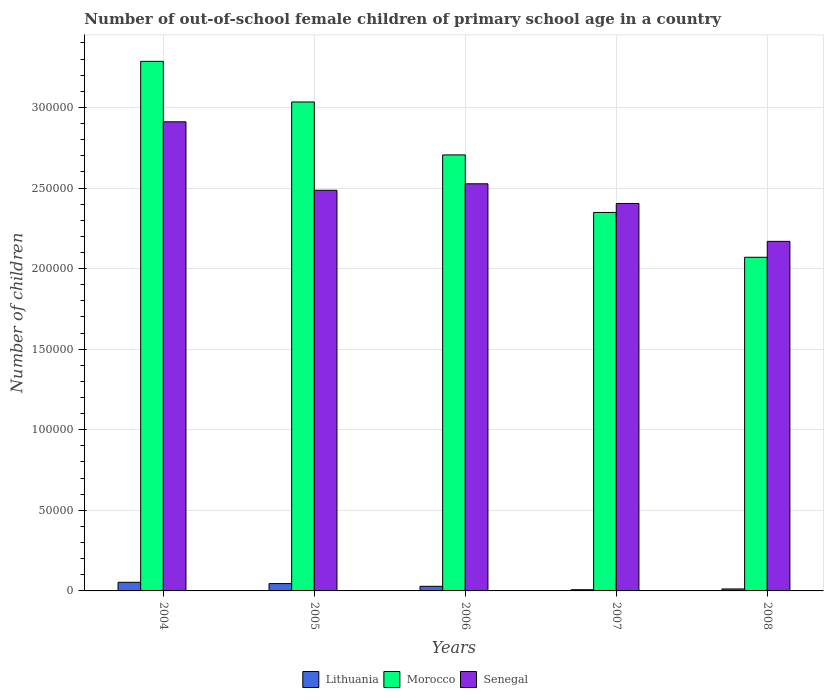How many different coloured bars are there?
Your answer should be very brief. 3. Are the number of bars per tick equal to the number of legend labels?
Provide a succinct answer. Yes. How many bars are there on the 1st tick from the right?
Provide a short and direct response. 3. In how many cases, is the number of bars for a given year not equal to the number of legend labels?
Offer a very short reply. 0. What is the number of out-of-school female children in Lithuania in 2006?
Your answer should be very brief. 2854. Across all years, what is the maximum number of out-of-school female children in Senegal?
Offer a very short reply. 2.91e+05. Across all years, what is the minimum number of out-of-school female children in Lithuania?
Ensure brevity in your answer.  739. In which year was the number of out-of-school female children in Senegal maximum?
Your answer should be compact. 2004. What is the total number of out-of-school female children in Senegal in the graph?
Offer a very short reply. 1.25e+06. What is the difference between the number of out-of-school female children in Senegal in 2005 and that in 2007?
Provide a succinct answer. 8182. What is the difference between the number of out-of-school female children in Lithuania in 2007 and the number of out-of-school female children in Senegal in 2004?
Give a very brief answer. -2.90e+05. What is the average number of out-of-school female children in Morocco per year?
Offer a very short reply. 2.69e+05. In the year 2005, what is the difference between the number of out-of-school female children in Lithuania and number of out-of-school female children in Senegal?
Provide a short and direct response. -2.44e+05. What is the ratio of the number of out-of-school female children in Morocco in 2004 to that in 2005?
Your response must be concise. 1.08. Is the difference between the number of out-of-school female children in Lithuania in 2006 and 2007 greater than the difference between the number of out-of-school female children in Senegal in 2006 and 2007?
Keep it short and to the point. No. What is the difference between the highest and the second highest number of out-of-school female children in Morocco?
Provide a short and direct response. 2.52e+04. What is the difference between the highest and the lowest number of out-of-school female children in Senegal?
Your response must be concise. 7.42e+04. What does the 3rd bar from the left in 2006 represents?
Keep it short and to the point. Senegal. What does the 1st bar from the right in 2006 represents?
Provide a short and direct response. Senegal. Is it the case that in every year, the sum of the number of out-of-school female children in Senegal and number of out-of-school female children in Morocco is greater than the number of out-of-school female children in Lithuania?
Your response must be concise. Yes. How many bars are there?
Your answer should be very brief. 15. Are all the bars in the graph horizontal?
Provide a short and direct response. No. What is the difference between two consecutive major ticks on the Y-axis?
Ensure brevity in your answer.  5.00e+04. Does the graph contain any zero values?
Your response must be concise. No. How are the legend labels stacked?
Offer a very short reply. Horizontal. What is the title of the graph?
Your answer should be compact. Number of out-of-school female children of primary school age in a country. Does "Solomon Islands" appear as one of the legend labels in the graph?
Your answer should be compact. No. What is the label or title of the Y-axis?
Your answer should be very brief. Number of children. What is the Number of children in Lithuania in 2004?
Your answer should be very brief. 5354. What is the Number of children in Morocco in 2004?
Your response must be concise. 3.29e+05. What is the Number of children in Senegal in 2004?
Provide a succinct answer. 2.91e+05. What is the Number of children in Lithuania in 2005?
Your answer should be compact. 4559. What is the Number of children of Morocco in 2005?
Provide a short and direct response. 3.03e+05. What is the Number of children of Senegal in 2005?
Keep it short and to the point. 2.49e+05. What is the Number of children in Lithuania in 2006?
Give a very brief answer. 2854. What is the Number of children in Morocco in 2006?
Your answer should be compact. 2.71e+05. What is the Number of children of Senegal in 2006?
Make the answer very short. 2.53e+05. What is the Number of children in Lithuania in 2007?
Make the answer very short. 739. What is the Number of children in Morocco in 2007?
Make the answer very short. 2.35e+05. What is the Number of children in Senegal in 2007?
Give a very brief answer. 2.40e+05. What is the Number of children of Lithuania in 2008?
Your answer should be very brief. 1215. What is the Number of children in Morocco in 2008?
Give a very brief answer. 2.07e+05. What is the Number of children in Senegal in 2008?
Make the answer very short. 2.17e+05. Across all years, what is the maximum Number of children in Lithuania?
Make the answer very short. 5354. Across all years, what is the maximum Number of children of Morocco?
Provide a short and direct response. 3.29e+05. Across all years, what is the maximum Number of children of Senegal?
Ensure brevity in your answer.  2.91e+05. Across all years, what is the minimum Number of children in Lithuania?
Your response must be concise. 739. Across all years, what is the minimum Number of children of Morocco?
Offer a terse response. 2.07e+05. Across all years, what is the minimum Number of children of Senegal?
Provide a succinct answer. 2.17e+05. What is the total Number of children in Lithuania in the graph?
Provide a succinct answer. 1.47e+04. What is the total Number of children in Morocco in the graph?
Your response must be concise. 1.34e+06. What is the total Number of children in Senegal in the graph?
Ensure brevity in your answer.  1.25e+06. What is the difference between the Number of children of Lithuania in 2004 and that in 2005?
Ensure brevity in your answer.  795. What is the difference between the Number of children in Morocco in 2004 and that in 2005?
Provide a succinct answer. 2.52e+04. What is the difference between the Number of children in Senegal in 2004 and that in 2005?
Make the answer very short. 4.25e+04. What is the difference between the Number of children of Lithuania in 2004 and that in 2006?
Offer a very short reply. 2500. What is the difference between the Number of children in Morocco in 2004 and that in 2006?
Make the answer very short. 5.80e+04. What is the difference between the Number of children in Senegal in 2004 and that in 2006?
Give a very brief answer. 3.85e+04. What is the difference between the Number of children of Lithuania in 2004 and that in 2007?
Your response must be concise. 4615. What is the difference between the Number of children in Morocco in 2004 and that in 2007?
Give a very brief answer. 9.38e+04. What is the difference between the Number of children in Senegal in 2004 and that in 2007?
Provide a succinct answer. 5.07e+04. What is the difference between the Number of children in Lithuania in 2004 and that in 2008?
Give a very brief answer. 4139. What is the difference between the Number of children of Morocco in 2004 and that in 2008?
Provide a short and direct response. 1.22e+05. What is the difference between the Number of children of Senegal in 2004 and that in 2008?
Your response must be concise. 7.42e+04. What is the difference between the Number of children in Lithuania in 2005 and that in 2006?
Offer a terse response. 1705. What is the difference between the Number of children in Morocco in 2005 and that in 2006?
Your answer should be very brief. 3.28e+04. What is the difference between the Number of children of Senegal in 2005 and that in 2006?
Provide a short and direct response. -4035. What is the difference between the Number of children in Lithuania in 2005 and that in 2007?
Your response must be concise. 3820. What is the difference between the Number of children in Morocco in 2005 and that in 2007?
Ensure brevity in your answer.  6.85e+04. What is the difference between the Number of children in Senegal in 2005 and that in 2007?
Ensure brevity in your answer.  8182. What is the difference between the Number of children in Lithuania in 2005 and that in 2008?
Make the answer very short. 3344. What is the difference between the Number of children of Morocco in 2005 and that in 2008?
Provide a short and direct response. 9.64e+04. What is the difference between the Number of children of Senegal in 2005 and that in 2008?
Your answer should be compact. 3.17e+04. What is the difference between the Number of children in Lithuania in 2006 and that in 2007?
Offer a very short reply. 2115. What is the difference between the Number of children of Morocco in 2006 and that in 2007?
Offer a terse response. 3.57e+04. What is the difference between the Number of children in Senegal in 2006 and that in 2007?
Your answer should be very brief. 1.22e+04. What is the difference between the Number of children of Lithuania in 2006 and that in 2008?
Ensure brevity in your answer.  1639. What is the difference between the Number of children of Morocco in 2006 and that in 2008?
Give a very brief answer. 6.35e+04. What is the difference between the Number of children in Senegal in 2006 and that in 2008?
Offer a terse response. 3.57e+04. What is the difference between the Number of children of Lithuania in 2007 and that in 2008?
Keep it short and to the point. -476. What is the difference between the Number of children of Morocco in 2007 and that in 2008?
Provide a short and direct response. 2.78e+04. What is the difference between the Number of children in Senegal in 2007 and that in 2008?
Your answer should be very brief. 2.35e+04. What is the difference between the Number of children of Lithuania in 2004 and the Number of children of Morocco in 2005?
Your answer should be very brief. -2.98e+05. What is the difference between the Number of children of Lithuania in 2004 and the Number of children of Senegal in 2005?
Provide a succinct answer. -2.43e+05. What is the difference between the Number of children of Morocco in 2004 and the Number of children of Senegal in 2005?
Provide a short and direct response. 8.00e+04. What is the difference between the Number of children of Lithuania in 2004 and the Number of children of Morocco in 2006?
Offer a very short reply. -2.65e+05. What is the difference between the Number of children of Lithuania in 2004 and the Number of children of Senegal in 2006?
Your response must be concise. -2.47e+05. What is the difference between the Number of children of Morocco in 2004 and the Number of children of Senegal in 2006?
Your response must be concise. 7.60e+04. What is the difference between the Number of children of Lithuania in 2004 and the Number of children of Morocco in 2007?
Offer a terse response. -2.30e+05. What is the difference between the Number of children of Lithuania in 2004 and the Number of children of Senegal in 2007?
Make the answer very short. -2.35e+05. What is the difference between the Number of children of Morocco in 2004 and the Number of children of Senegal in 2007?
Provide a succinct answer. 8.82e+04. What is the difference between the Number of children in Lithuania in 2004 and the Number of children in Morocco in 2008?
Your answer should be compact. -2.02e+05. What is the difference between the Number of children in Lithuania in 2004 and the Number of children in Senegal in 2008?
Keep it short and to the point. -2.12e+05. What is the difference between the Number of children in Morocco in 2004 and the Number of children in Senegal in 2008?
Provide a succinct answer. 1.12e+05. What is the difference between the Number of children in Lithuania in 2005 and the Number of children in Morocco in 2006?
Make the answer very short. -2.66e+05. What is the difference between the Number of children in Lithuania in 2005 and the Number of children in Senegal in 2006?
Your response must be concise. -2.48e+05. What is the difference between the Number of children of Morocco in 2005 and the Number of children of Senegal in 2006?
Provide a short and direct response. 5.08e+04. What is the difference between the Number of children of Lithuania in 2005 and the Number of children of Morocco in 2007?
Offer a very short reply. -2.30e+05. What is the difference between the Number of children of Lithuania in 2005 and the Number of children of Senegal in 2007?
Keep it short and to the point. -2.36e+05. What is the difference between the Number of children of Morocco in 2005 and the Number of children of Senegal in 2007?
Your answer should be very brief. 6.30e+04. What is the difference between the Number of children of Lithuania in 2005 and the Number of children of Morocco in 2008?
Keep it short and to the point. -2.02e+05. What is the difference between the Number of children in Lithuania in 2005 and the Number of children in Senegal in 2008?
Provide a short and direct response. -2.12e+05. What is the difference between the Number of children of Morocco in 2005 and the Number of children of Senegal in 2008?
Offer a terse response. 8.65e+04. What is the difference between the Number of children in Lithuania in 2006 and the Number of children in Morocco in 2007?
Your response must be concise. -2.32e+05. What is the difference between the Number of children in Lithuania in 2006 and the Number of children in Senegal in 2007?
Make the answer very short. -2.38e+05. What is the difference between the Number of children of Morocco in 2006 and the Number of children of Senegal in 2007?
Give a very brief answer. 3.01e+04. What is the difference between the Number of children of Lithuania in 2006 and the Number of children of Morocco in 2008?
Offer a very short reply. -2.04e+05. What is the difference between the Number of children of Lithuania in 2006 and the Number of children of Senegal in 2008?
Keep it short and to the point. -2.14e+05. What is the difference between the Number of children of Morocco in 2006 and the Number of children of Senegal in 2008?
Ensure brevity in your answer.  5.37e+04. What is the difference between the Number of children in Lithuania in 2007 and the Number of children in Morocco in 2008?
Ensure brevity in your answer.  -2.06e+05. What is the difference between the Number of children in Lithuania in 2007 and the Number of children in Senegal in 2008?
Make the answer very short. -2.16e+05. What is the difference between the Number of children in Morocco in 2007 and the Number of children in Senegal in 2008?
Offer a very short reply. 1.79e+04. What is the average Number of children of Lithuania per year?
Provide a short and direct response. 2944.2. What is the average Number of children in Morocco per year?
Make the answer very short. 2.69e+05. What is the average Number of children in Senegal per year?
Ensure brevity in your answer.  2.50e+05. In the year 2004, what is the difference between the Number of children in Lithuania and Number of children in Morocco?
Give a very brief answer. -3.23e+05. In the year 2004, what is the difference between the Number of children in Lithuania and Number of children in Senegal?
Offer a very short reply. -2.86e+05. In the year 2004, what is the difference between the Number of children in Morocco and Number of children in Senegal?
Offer a very short reply. 3.75e+04. In the year 2005, what is the difference between the Number of children of Lithuania and Number of children of Morocco?
Provide a short and direct response. -2.99e+05. In the year 2005, what is the difference between the Number of children of Lithuania and Number of children of Senegal?
Ensure brevity in your answer.  -2.44e+05. In the year 2005, what is the difference between the Number of children in Morocco and Number of children in Senegal?
Your answer should be compact. 5.48e+04. In the year 2006, what is the difference between the Number of children of Lithuania and Number of children of Morocco?
Ensure brevity in your answer.  -2.68e+05. In the year 2006, what is the difference between the Number of children of Lithuania and Number of children of Senegal?
Your answer should be very brief. -2.50e+05. In the year 2006, what is the difference between the Number of children of Morocco and Number of children of Senegal?
Your answer should be very brief. 1.79e+04. In the year 2007, what is the difference between the Number of children in Lithuania and Number of children in Morocco?
Offer a very short reply. -2.34e+05. In the year 2007, what is the difference between the Number of children of Lithuania and Number of children of Senegal?
Offer a terse response. -2.40e+05. In the year 2007, what is the difference between the Number of children in Morocco and Number of children in Senegal?
Your answer should be very brief. -5563. In the year 2008, what is the difference between the Number of children in Lithuania and Number of children in Morocco?
Your response must be concise. -2.06e+05. In the year 2008, what is the difference between the Number of children of Lithuania and Number of children of Senegal?
Offer a terse response. -2.16e+05. In the year 2008, what is the difference between the Number of children of Morocco and Number of children of Senegal?
Your answer should be compact. -9867. What is the ratio of the Number of children of Lithuania in 2004 to that in 2005?
Keep it short and to the point. 1.17. What is the ratio of the Number of children in Morocco in 2004 to that in 2005?
Ensure brevity in your answer.  1.08. What is the ratio of the Number of children in Senegal in 2004 to that in 2005?
Offer a very short reply. 1.17. What is the ratio of the Number of children of Lithuania in 2004 to that in 2006?
Give a very brief answer. 1.88. What is the ratio of the Number of children in Morocco in 2004 to that in 2006?
Your answer should be compact. 1.21. What is the ratio of the Number of children in Senegal in 2004 to that in 2006?
Your answer should be very brief. 1.15. What is the ratio of the Number of children in Lithuania in 2004 to that in 2007?
Provide a succinct answer. 7.24. What is the ratio of the Number of children in Morocco in 2004 to that in 2007?
Ensure brevity in your answer.  1.4. What is the ratio of the Number of children of Senegal in 2004 to that in 2007?
Give a very brief answer. 1.21. What is the ratio of the Number of children of Lithuania in 2004 to that in 2008?
Provide a short and direct response. 4.41. What is the ratio of the Number of children in Morocco in 2004 to that in 2008?
Ensure brevity in your answer.  1.59. What is the ratio of the Number of children in Senegal in 2004 to that in 2008?
Provide a succinct answer. 1.34. What is the ratio of the Number of children of Lithuania in 2005 to that in 2006?
Your answer should be compact. 1.6. What is the ratio of the Number of children in Morocco in 2005 to that in 2006?
Offer a very short reply. 1.12. What is the ratio of the Number of children in Lithuania in 2005 to that in 2007?
Give a very brief answer. 6.17. What is the ratio of the Number of children of Morocco in 2005 to that in 2007?
Provide a short and direct response. 1.29. What is the ratio of the Number of children in Senegal in 2005 to that in 2007?
Your answer should be very brief. 1.03. What is the ratio of the Number of children of Lithuania in 2005 to that in 2008?
Ensure brevity in your answer.  3.75. What is the ratio of the Number of children of Morocco in 2005 to that in 2008?
Offer a very short reply. 1.47. What is the ratio of the Number of children in Senegal in 2005 to that in 2008?
Offer a terse response. 1.15. What is the ratio of the Number of children of Lithuania in 2006 to that in 2007?
Your answer should be compact. 3.86. What is the ratio of the Number of children of Morocco in 2006 to that in 2007?
Give a very brief answer. 1.15. What is the ratio of the Number of children of Senegal in 2006 to that in 2007?
Ensure brevity in your answer.  1.05. What is the ratio of the Number of children of Lithuania in 2006 to that in 2008?
Keep it short and to the point. 2.35. What is the ratio of the Number of children of Morocco in 2006 to that in 2008?
Give a very brief answer. 1.31. What is the ratio of the Number of children of Senegal in 2006 to that in 2008?
Your answer should be very brief. 1.16. What is the ratio of the Number of children of Lithuania in 2007 to that in 2008?
Offer a very short reply. 0.61. What is the ratio of the Number of children of Morocco in 2007 to that in 2008?
Offer a very short reply. 1.13. What is the ratio of the Number of children in Senegal in 2007 to that in 2008?
Your answer should be compact. 1.11. What is the difference between the highest and the second highest Number of children of Lithuania?
Ensure brevity in your answer.  795. What is the difference between the highest and the second highest Number of children of Morocco?
Keep it short and to the point. 2.52e+04. What is the difference between the highest and the second highest Number of children of Senegal?
Ensure brevity in your answer.  3.85e+04. What is the difference between the highest and the lowest Number of children of Lithuania?
Make the answer very short. 4615. What is the difference between the highest and the lowest Number of children of Morocco?
Your response must be concise. 1.22e+05. What is the difference between the highest and the lowest Number of children of Senegal?
Provide a succinct answer. 7.42e+04. 